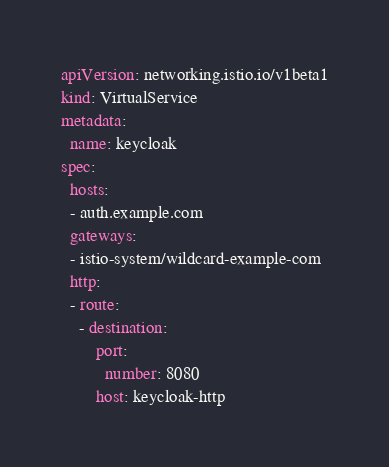<code> <loc_0><loc_0><loc_500><loc_500><_YAML_>apiVersion: networking.istio.io/v1beta1
kind: VirtualService
metadata:
  name: keycloak
spec:
  hosts:
  - auth.example.com
  gateways:
  - istio-system/wildcard-example-com
  http:
  - route:
    - destination:
        port:
          number: 8080
        host: keycloak-http
</code> 